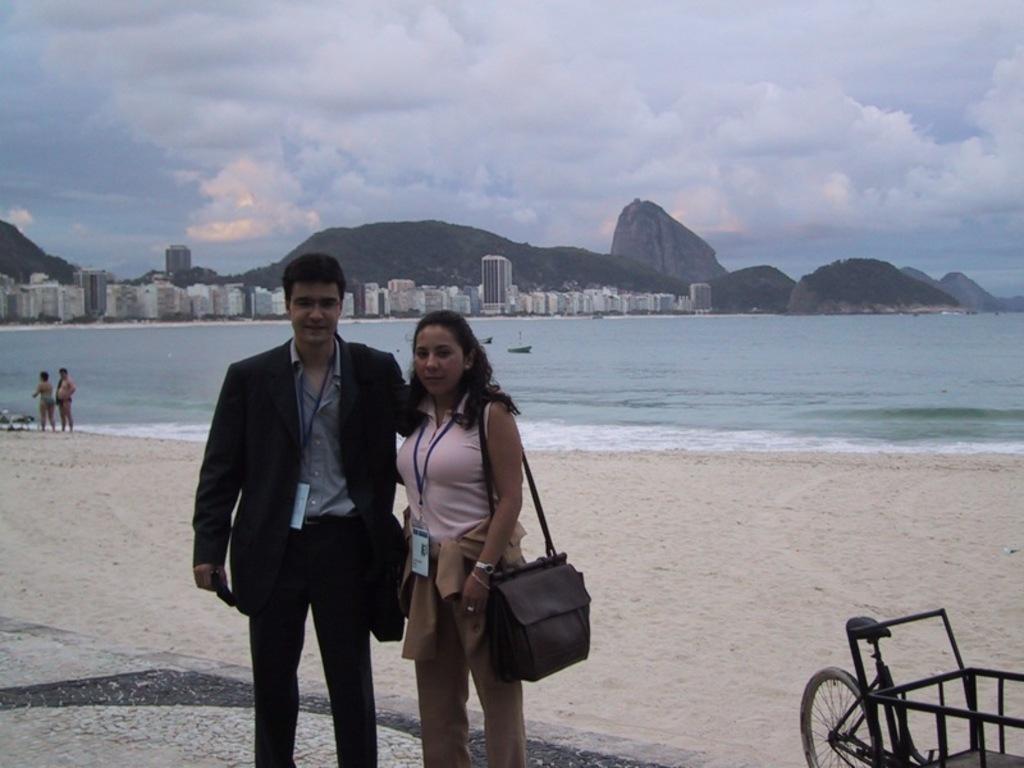How would you summarize this image in a sentence or two? In this image I can see a man and a woman are standing, I can also see she is carrying a bag. In the background I can see few more people, water and number of buildings. Here I can see a cloudy sky. 